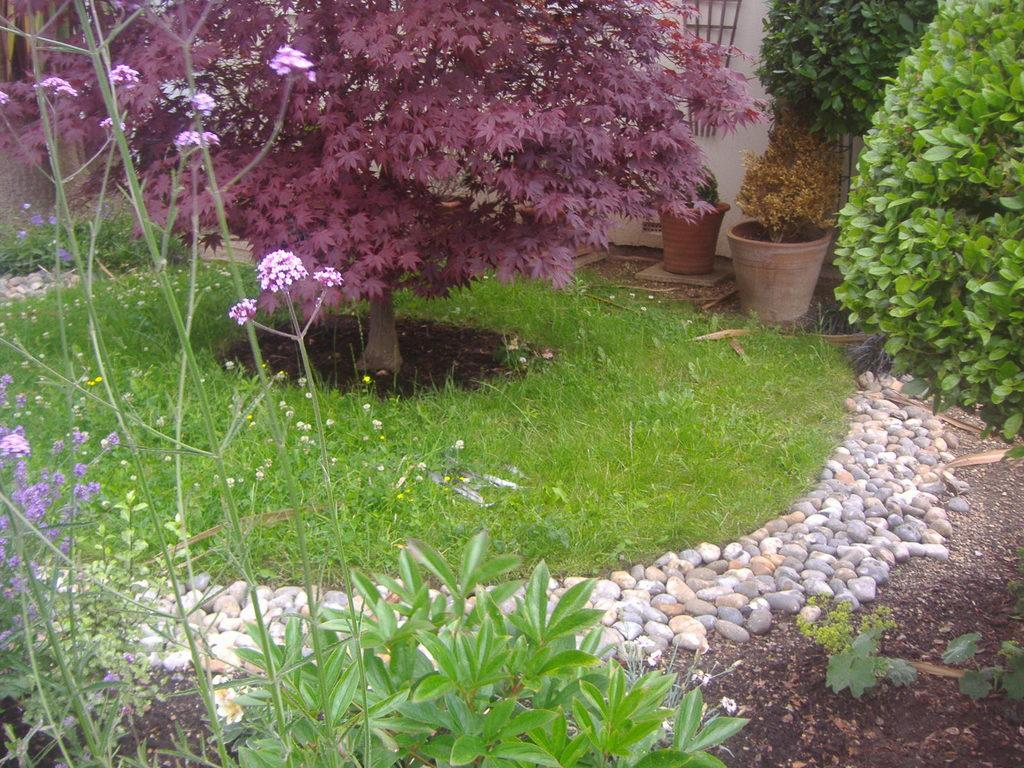What type of vegetation can be seen in the image? There is grass, plants, and flowers visible in the image. What objects are present that might be used for holding plants? There are pots in the image that might be used for holding plants. What is visible on the ground in the image? The ground is visible in the image, along with pebbles. What can be seen in the background of the image? There is a wall in the background of the image. Can you tell me how many beetles are crawling on the actor in the image? There is no actor or beetles present in the image; it features plants, pots, and a wall in the background. 